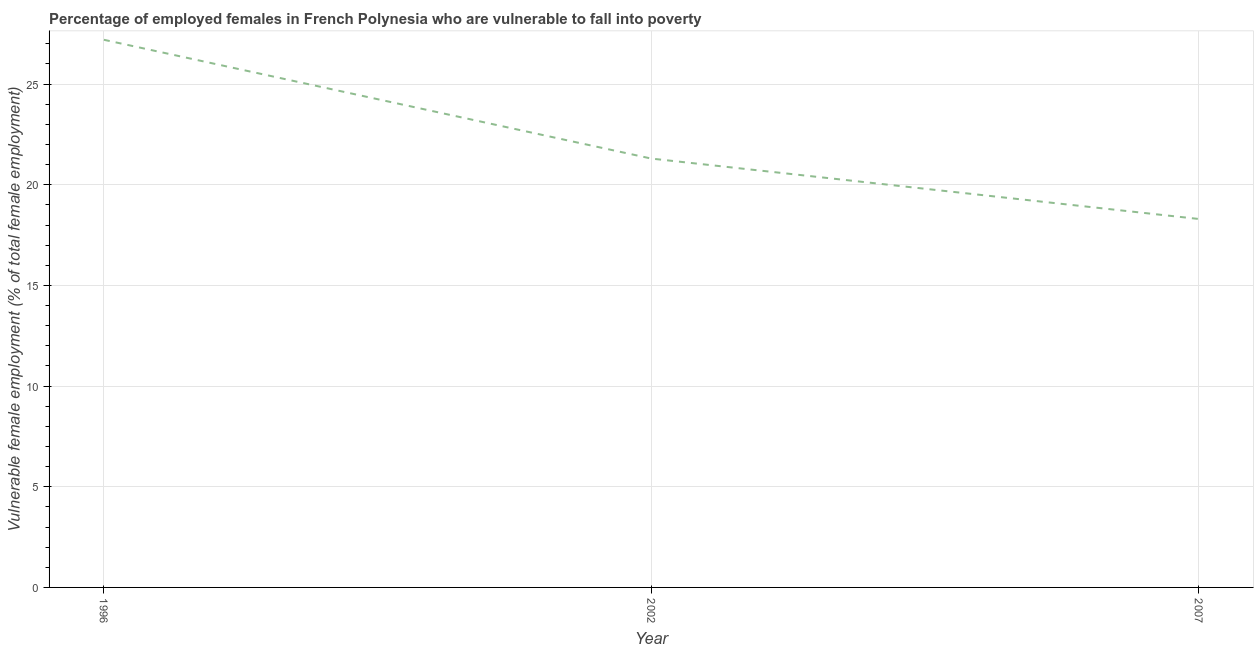What is the percentage of employed females who are vulnerable to fall into poverty in 1996?
Provide a succinct answer. 27.2. Across all years, what is the maximum percentage of employed females who are vulnerable to fall into poverty?
Ensure brevity in your answer.  27.2. Across all years, what is the minimum percentage of employed females who are vulnerable to fall into poverty?
Make the answer very short. 18.3. In which year was the percentage of employed females who are vulnerable to fall into poverty minimum?
Your answer should be compact. 2007. What is the sum of the percentage of employed females who are vulnerable to fall into poverty?
Ensure brevity in your answer.  66.8. What is the difference between the percentage of employed females who are vulnerable to fall into poverty in 2002 and 2007?
Offer a very short reply. 3. What is the average percentage of employed females who are vulnerable to fall into poverty per year?
Your response must be concise. 22.27. What is the median percentage of employed females who are vulnerable to fall into poverty?
Keep it short and to the point. 21.3. In how many years, is the percentage of employed females who are vulnerable to fall into poverty greater than 9 %?
Provide a succinct answer. 3. What is the ratio of the percentage of employed females who are vulnerable to fall into poverty in 2002 to that in 2007?
Keep it short and to the point. 1.16. What is the difference between the highest and the second highest percentage of employed females who are vulnerable to fall into poverty?
Keep it short and to the point. 5.9. Is the sum of the percentage of employed females who are vulnerable to fall into poverty in 1996 and 2002 greater than the maximum percentage of employed females who are vulnerable to fall into poverty across all years?
Make the answer very short. Yes. What is the difference between the highest and the lowest percentage of employed females who are vulnerable to fall into poverty?
Give a very brief answer. 8.9. In how many years, is the percentage of employed females who are vulnerable to fall into poverty greater than the average percentage of employed females who are vulnerable to fall into poverty taken over all years?
Ensure brevity in your answer.  1. Does the percentage of employed females who are vulnerable to fall into poverty monotonically increase over the years?
Give a very brief answer. No. How many lines are there?
Your answer should be very brief. 1. How many years are there in the graph?
Your response must be concise. 3. Are the values on the major ticks of Y-axis written in scientific E-notation?
Offer a terse response. No. Does the graph contain any zero values?
Provide a short and direct response. No. What is the title of the graph?
Offer a terse response. Percentage of employed females in French Polynesia who are vulnerable to fall into poverty. What is the label or title of the Y-axis?
Provide a short and direct response. Vulnerable female employment (% of total female employment). What is the Vulnerable female employment (% of total female employment) in 1996?
Make the answer very short. 27.2. What is the Vulnerable female employment (% of total female employment) of 2002?
Offer a terse response. 21.3. What is the Vulnerable female employment (% of total female employment) of 2007?
Your response must be concise. 18.3. What is the difference between the Vulnerable female employment (% of total female employment) in 1996 and 2002?
Give a very brief answer. 5.9. What is the ratio of the Vulnerable female employment (% of total female employment) in 1996 to that in 2002?
Offer a very short reply. 1.28. What is the ratio of the Vulnerable female employment (% of total female employment) in 1996 to that in 2007?
Provide a succinct answer. 1.49. What is the ratio of the Vulnerable female employment (% of total female employment) in 2002 to that in 2007?
Provide a succinct answer. 1.16. 